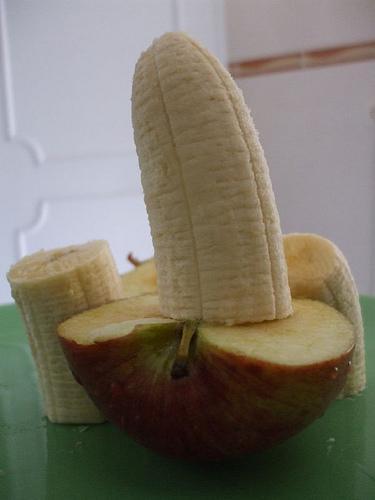Does the description: "The dining table is touching the apple." accurately reflect the image?
Answer yes or no. Yes. Is the caption "The apple is on the dining table." a true representation of the image?
Answer yes or no. Yes. 